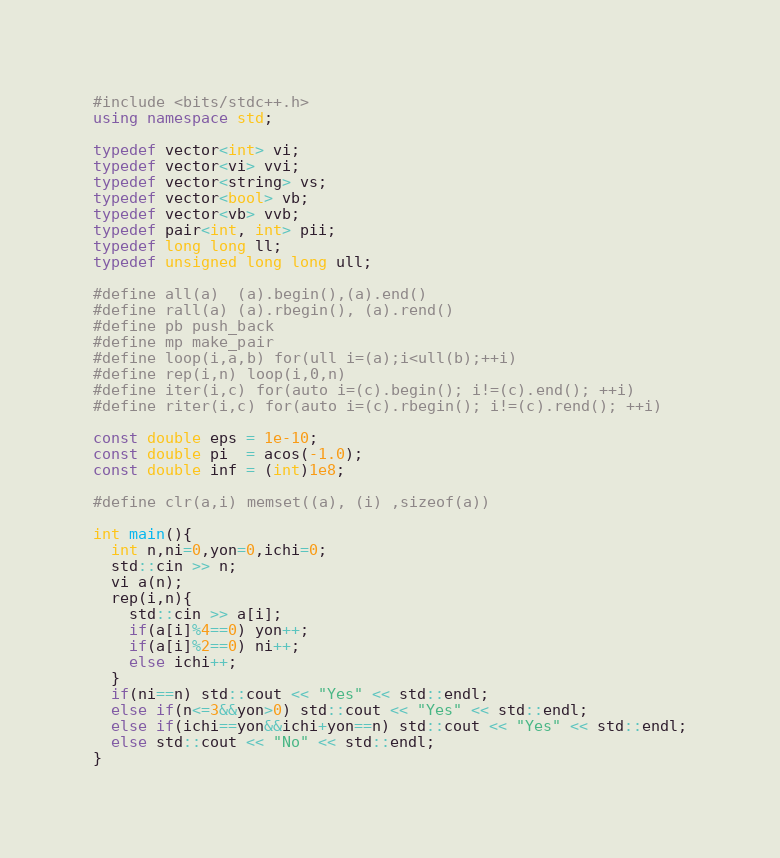Convert code to text. <code><loc_0><loc_0><loc_500><loc_500><_C++_>#include <bits/stdc++.h>
using namespace std;

typedef vector<int> vi;
typedef vector<vi> vvi;
typedef vector<string> vs;
typedef vector<bool> vb;
typedef vector<vb> vvb;
typedef pair<int, int> pii;
typedef long long ll;
typedef unsigned long long ull;

#define all(a)  (a).begin(),(a).end()
#define rall(a) (a).rbegin(), (a).rend()
#define pb push_back
#define mp make_pair
#define loop(i,a,b) for(ull i=(a);i<ull(b);++i)
#define rep(i,n) loop(i,0,n)
#define iter(i,c) for(auto i=(c).begin(); i!=(c).end(); ++i)
#define riter(i,c) for(auto i=(c).rbegin(); i!=(c).rend(); ++i)

const double eps = 1e-10;
const double pi  = acos(-1.0);
const double inf = (int)1e8;

#define clr(a,i) memset((a), (i) ,sizeof(a))

int main(){
  int n,ni=0,yon=0,ichi=0;
  std::cin >> n;
  vi a(n);
  rep(i,n){
    std::cin >> a[i];
    if(a[i]%4==0) yon++;
    if(a[i]%2==0) ni++;
    else ichi++;
  }
  if(ni==n) std::cout << "Yes" << std::endl;
  else if(n<=3&&yon>0) std::cout << "Yes" << std::endl;
  else if(ichi==yon&&ichi+yon==n) std::cout << "Yes" << std::endl;
  else std::cout << "No" << std::endl;
}
</code> 